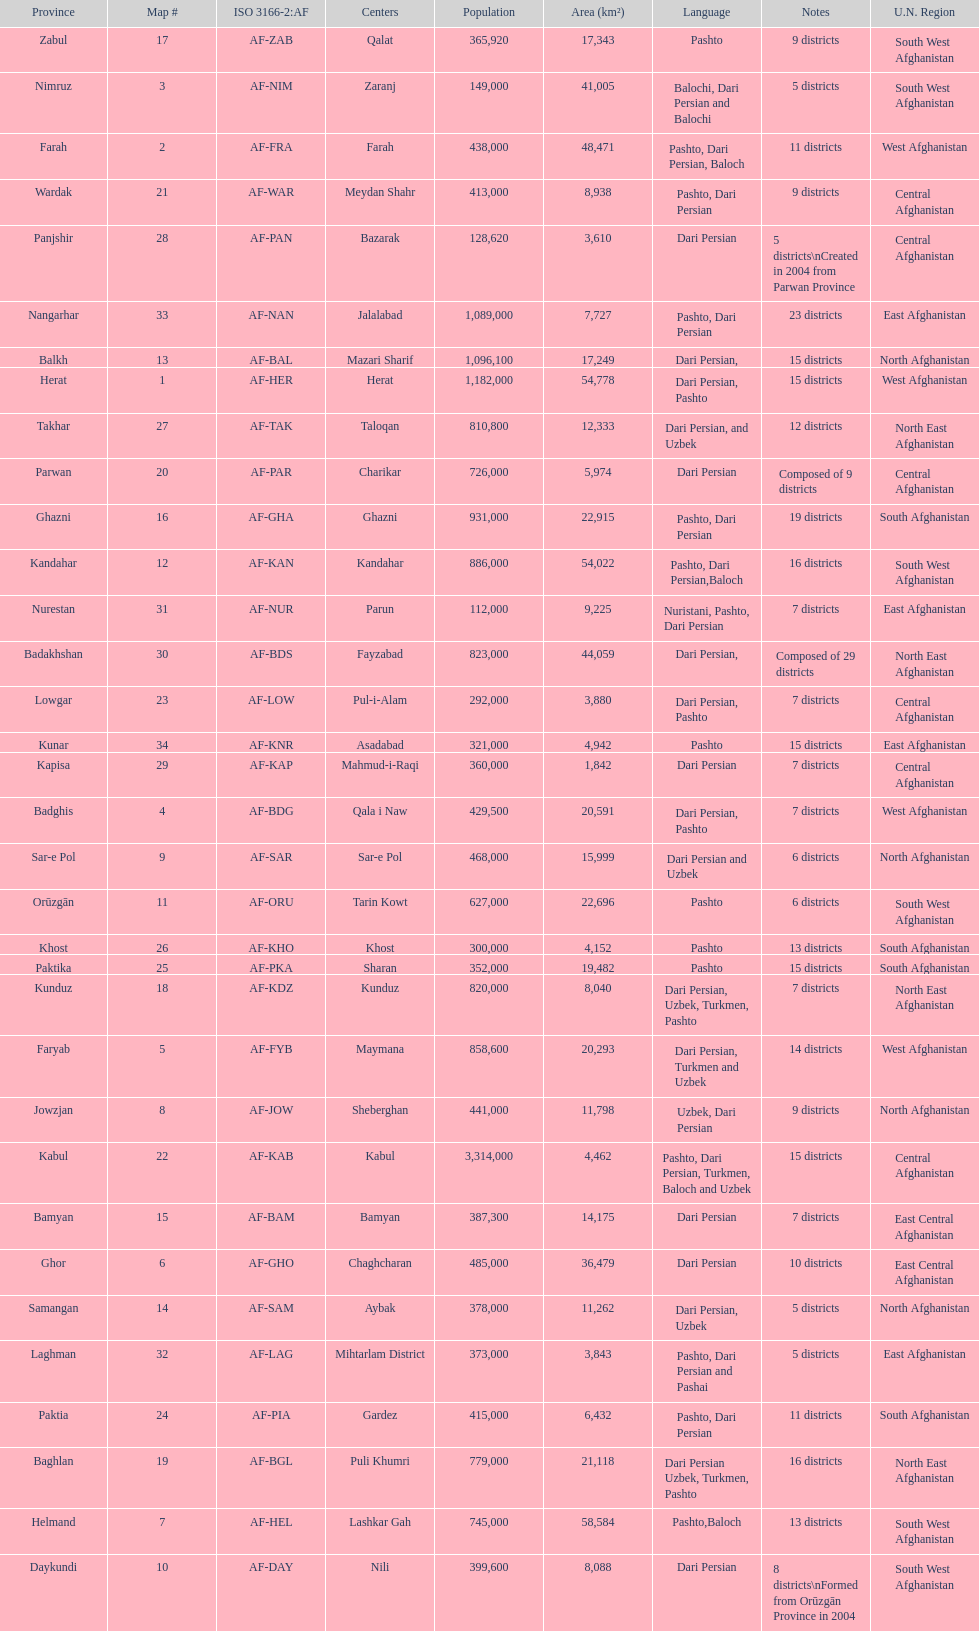Does ghor or farah have more districts? Farah. 